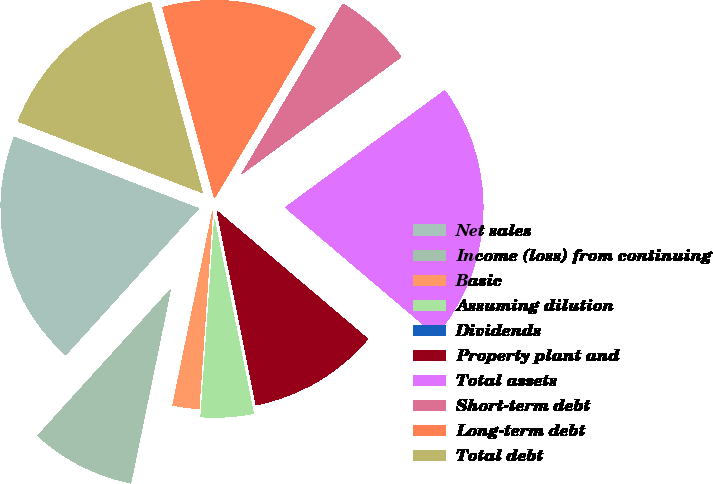Convert chart to OTSL. <chart><loc_0><loc_0><loc_500><loc_500><pie_chart><fcel>Net sales<fcel>Income (loss) from continuing<fcel>Basic<fcel>Assuming dilution<fcel>Dividends<fcel>Property plant and<fcel>Total assets<fcel>Short-term debt<fcel>Long-term debt<fcel>Total debt<nl><fcel>19.15%<fcel>8.51%<fcel>2.13%<fcel>4.26%<fcel>0.0%<fcel>10.64%<fcel>21.28%<fcel>6.38%<fcel>12.77%<fcel>14.89%<nl></chart> 